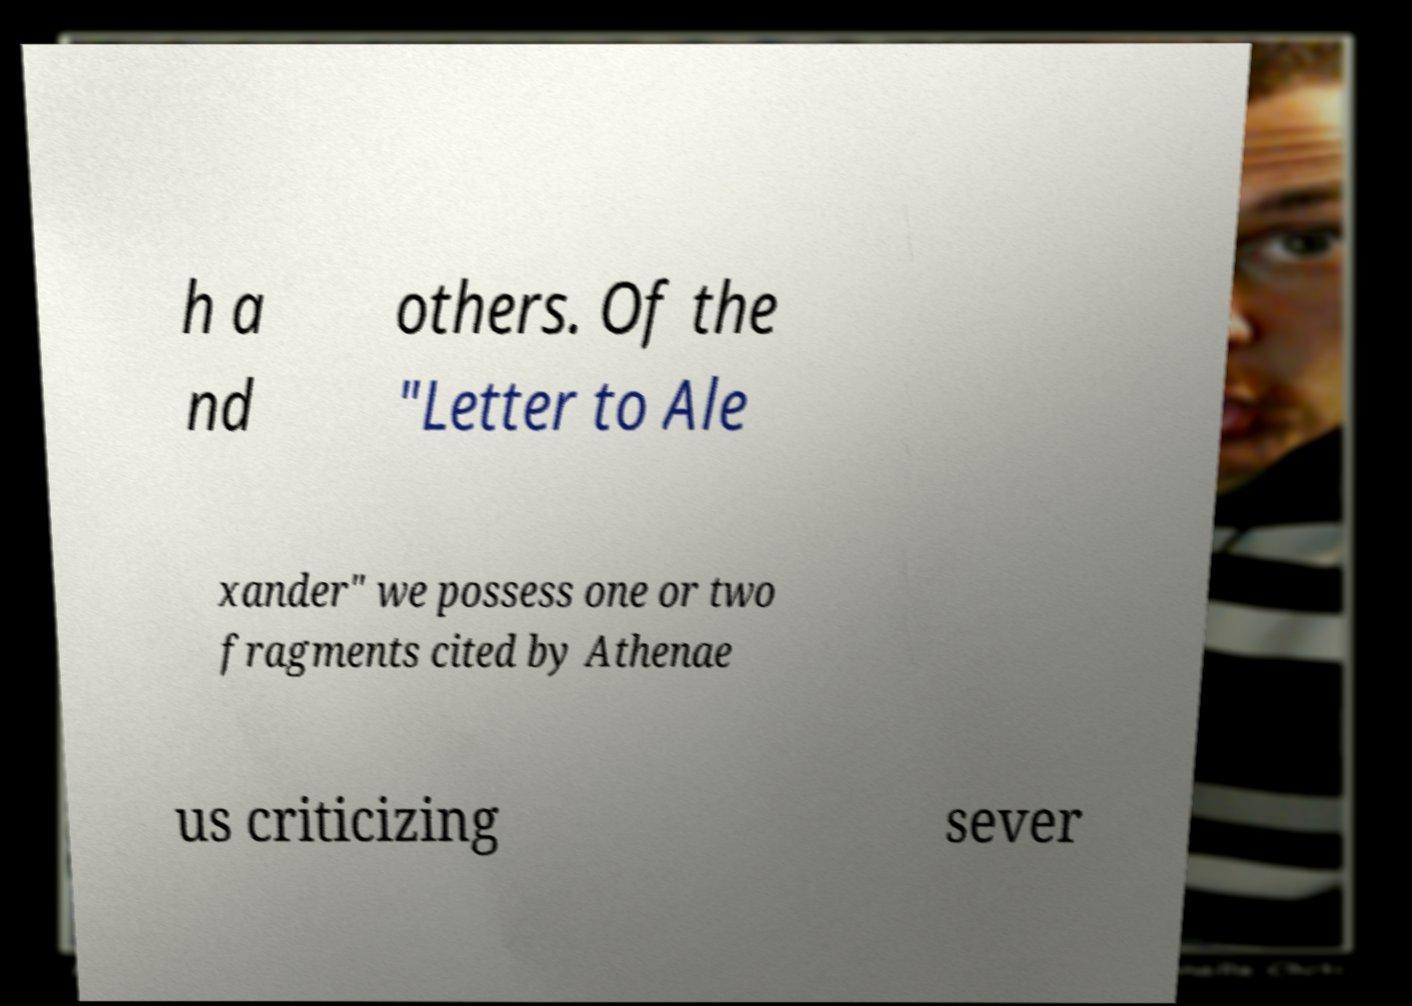Could you assist in decoding the text presented in this image and type it out clearly? h a nd others. Of the "Letter to Ale xander" we possess one or two fragments cited by Athenae us criticizing sever 